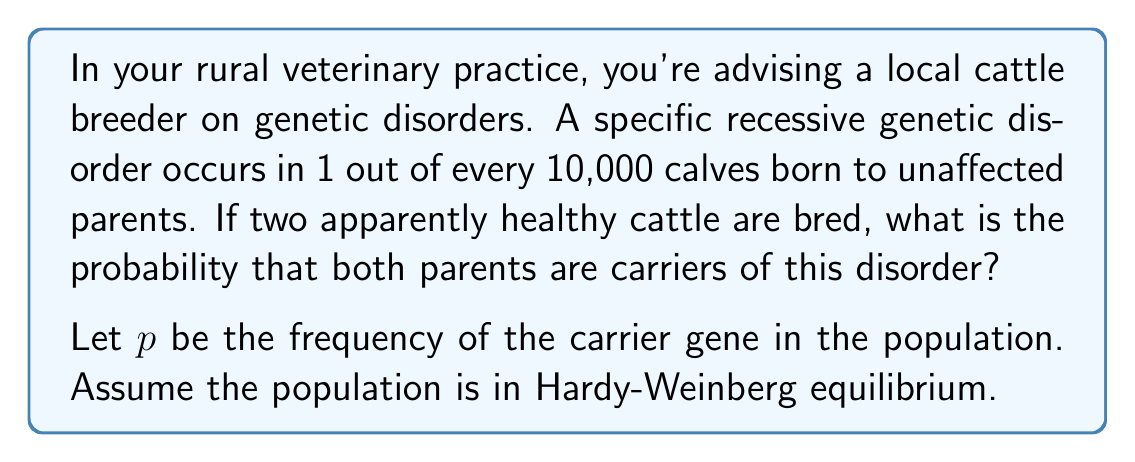Can you solve this math problem? To solve this problem, we'll use the Hardy-Weinberg principle and the given information:

1) In Hardy-Weinberg equilibrium, for a recessive trait:
   $p^2$ = frequency of affected individuals
   $2pq$ = frequency of carriers
   $q^2$ = frequency of unaffected non-carriers
   where $p + q = 1$

2) We're told that 1 in 10,000 calves born to unaffected parents have the disorder. This means:
   $p^2 = \frac{1}{10000} = 0.0001$

3) To find $p$, we take the square root:
   $p = \sqrt{0.0001} = 0.01$

4) Now we can calculate $q$:
   $q = 1 - p = 1 - 0.01 = 0.99$

5) The frequency of carriers is $2pq$:
   $2pq = 2(0.01)(0.99) = 0.0198$

6) The probability that both parents are carriers is the square of this frequency:
   $(0.0198)^2 \approx 0.000392$

Therefore, the probability that both parents are carriers is approximately 0.0392% or about 1 in 2,551.
Answer: $0.000392$ or $3.92 \times 10^{-4}$ 